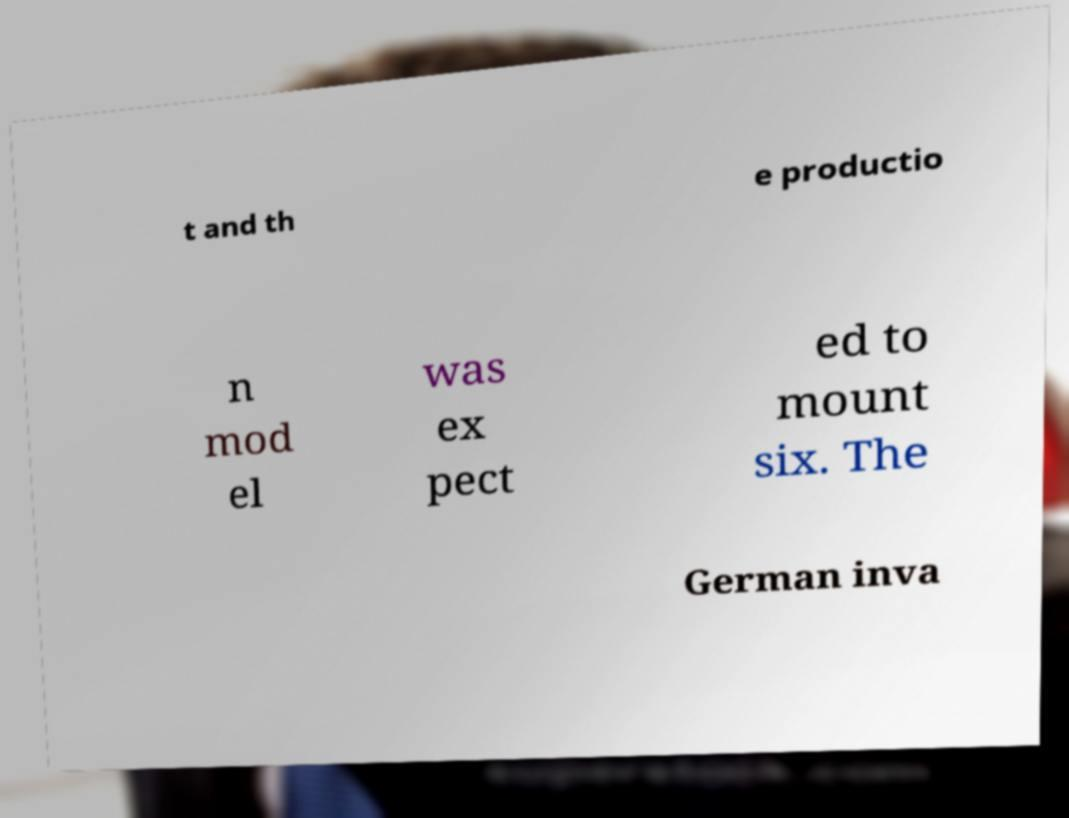Could you assist in decoding the text presented in this image and type it out clearly? t and th e productio n mod el was ex pect ed to mount six. The German inva 